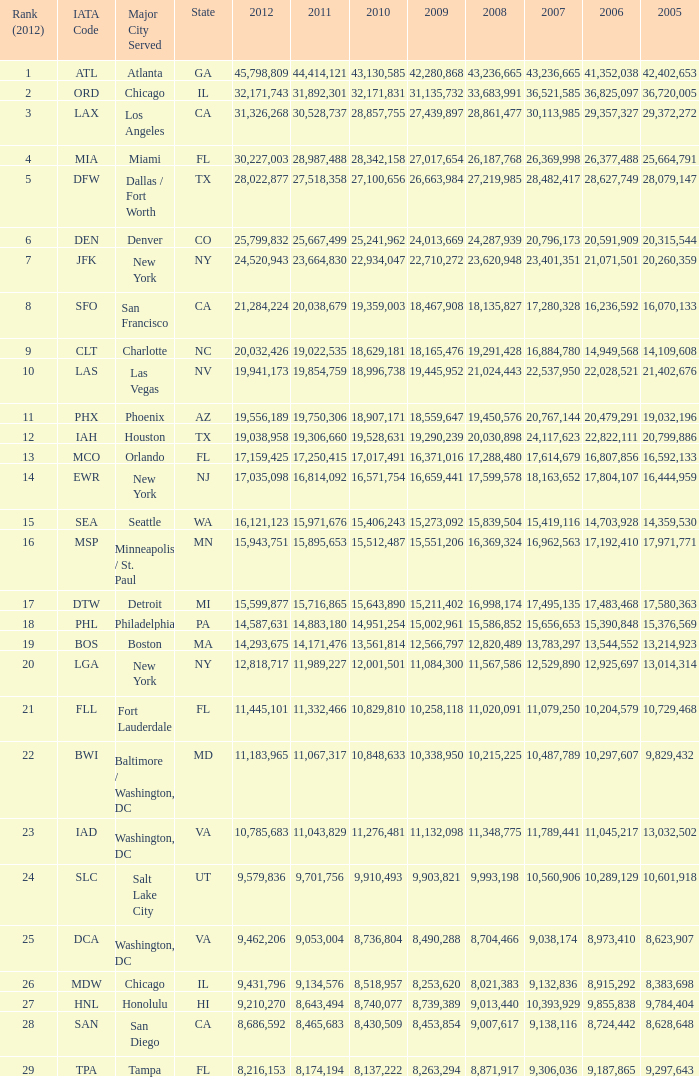What is the greatest 2010 for Miami, Fl? 28342158.0. 